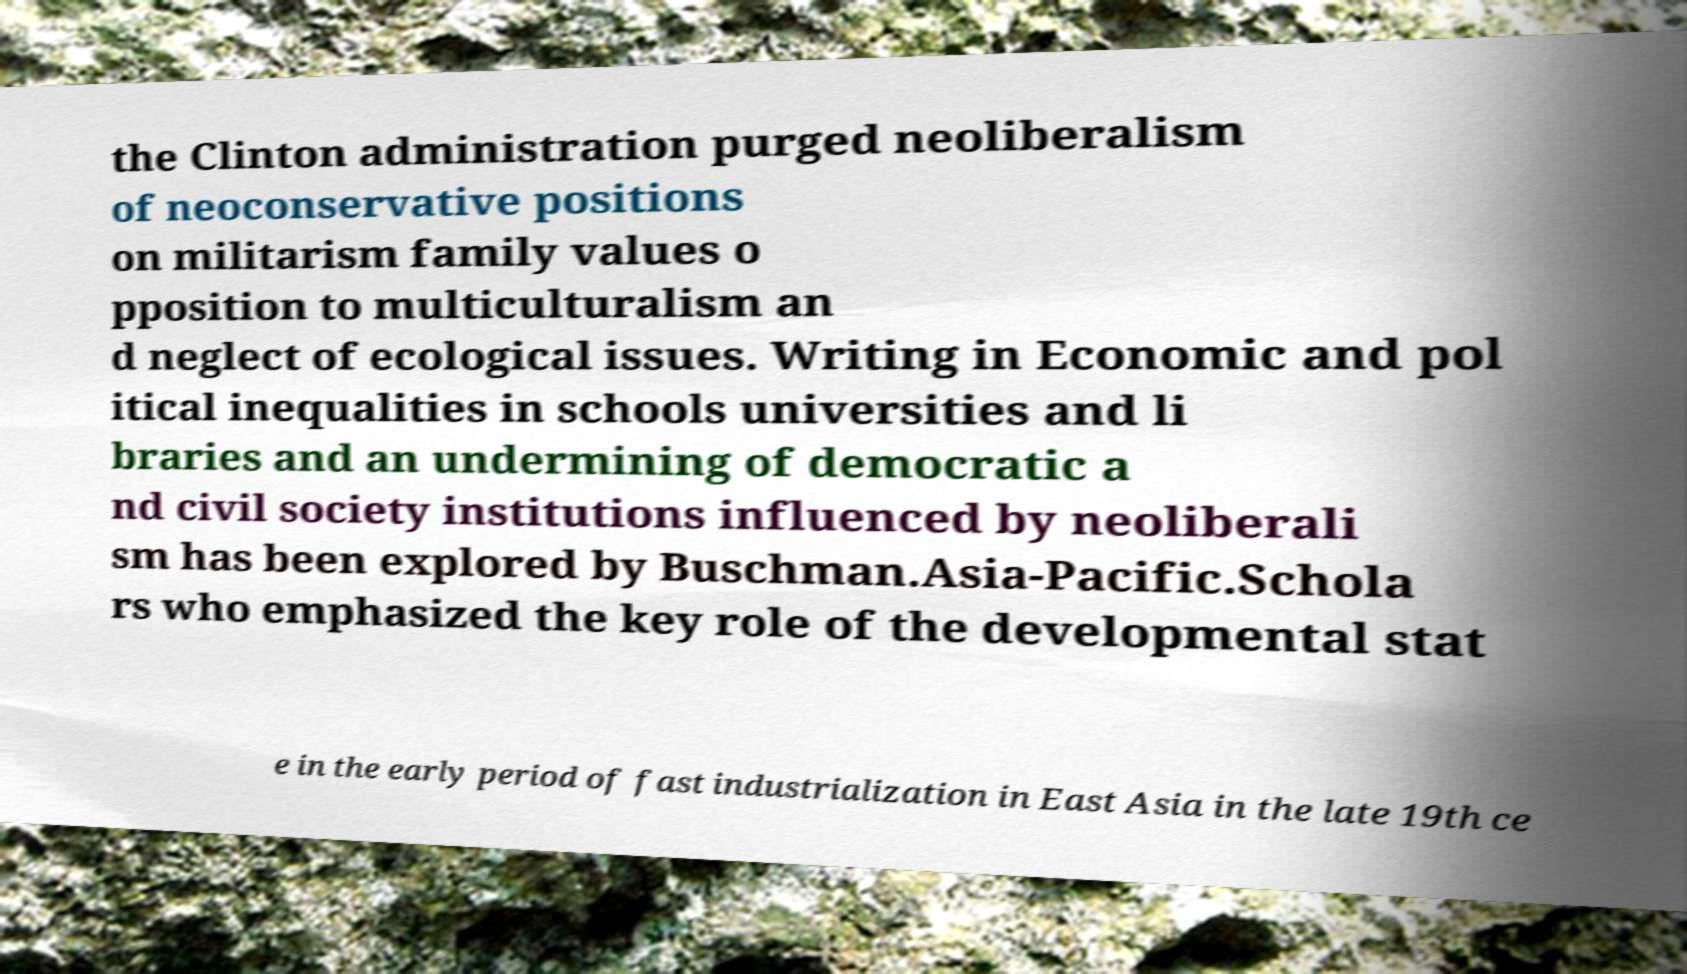Please read and relay the text visible in this image. What does it say? the Clinton administration purged neoliberalism of neoconservative positions on militarism family values o pposition to multiculturalism an d neglect of ecological issues. Writing in Economic and pol itical inequalities in schools universities and li braries and an undermining of democratic a nd civil society institutions influenced by neoliberali sm has been explored by Buschman.Asia-Pacific.Schola rs who emphasized the key role of the developmental stat e in the early period of fast industrialization in East Asia in the late 19th ce 